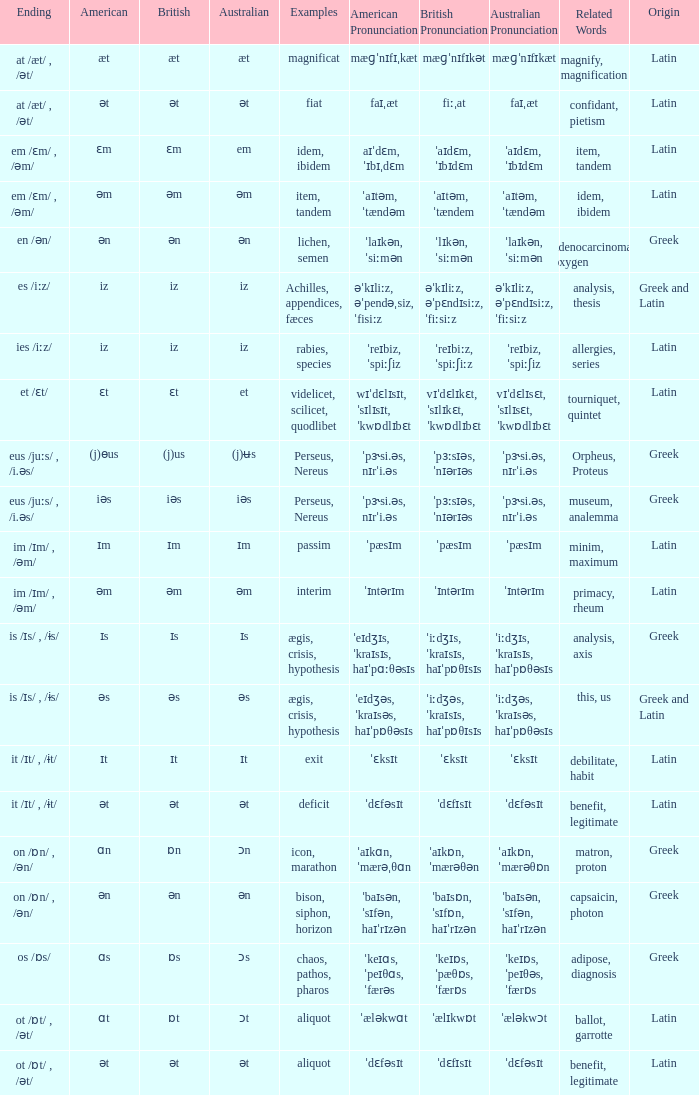Which Ending has British of iz, and Examples of achilles, appendices, fæces? Es /iːz/. 